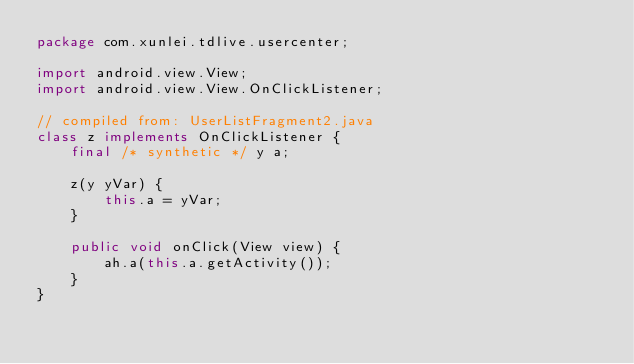Convert code to text. <code><loc_0><loc_0><loc_500><loc_500><_Java_>package com.xunlei.tdlive.usercenter;

import android.view.View;
import android.view.View.OnClickListener;

// compiled from: UserListFragment2.java
class z implements OnClickListener {
    final /* synthetic */ y a;

    z(y yVar) {
        this.a = yVar;
    }

    public void onClick(View view) {
        ah.a(this.a.getActivity());
    }
}
</code> 